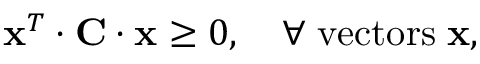<formula> <loc_0><loc_0><loc_500><loc_500>{ x } ^ { T } \cdot { C } \cdot { x } \geq 0 , \quad \forall \, v e c t o r s \, { x } ,</formula> 